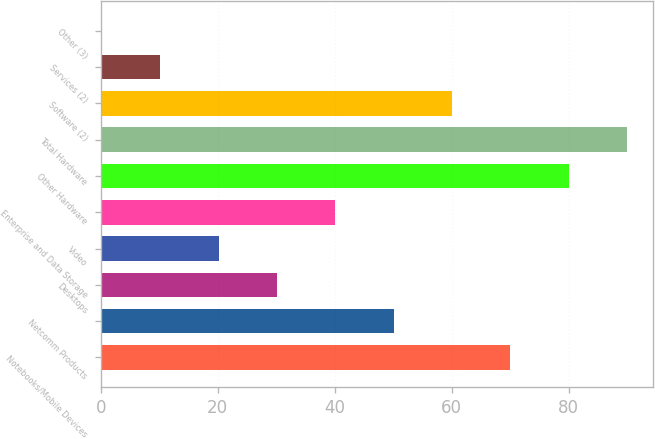<chart> <loc_0><loc_0><loc_500><loc_500><bar_chart><fcel>Notebooks/Mobile Devices<fcel>Netcomm Products<fcel>Desktops<fcel>Video<fcel>Enterprise and Data Storage<fcel>Other Hardware<fcel>Total Hardware<fcel>Software (2)<fcel>Services (2)<fcel>Other (3)<nl><fcel>70.06<fcel>50.1<fcel>30.14<fcel>20.16<fcel>40.12<fcel>80.04<fcel>90.02<fcel>60.08<fcel>10.18<fcel>0.2<nl></chart> 